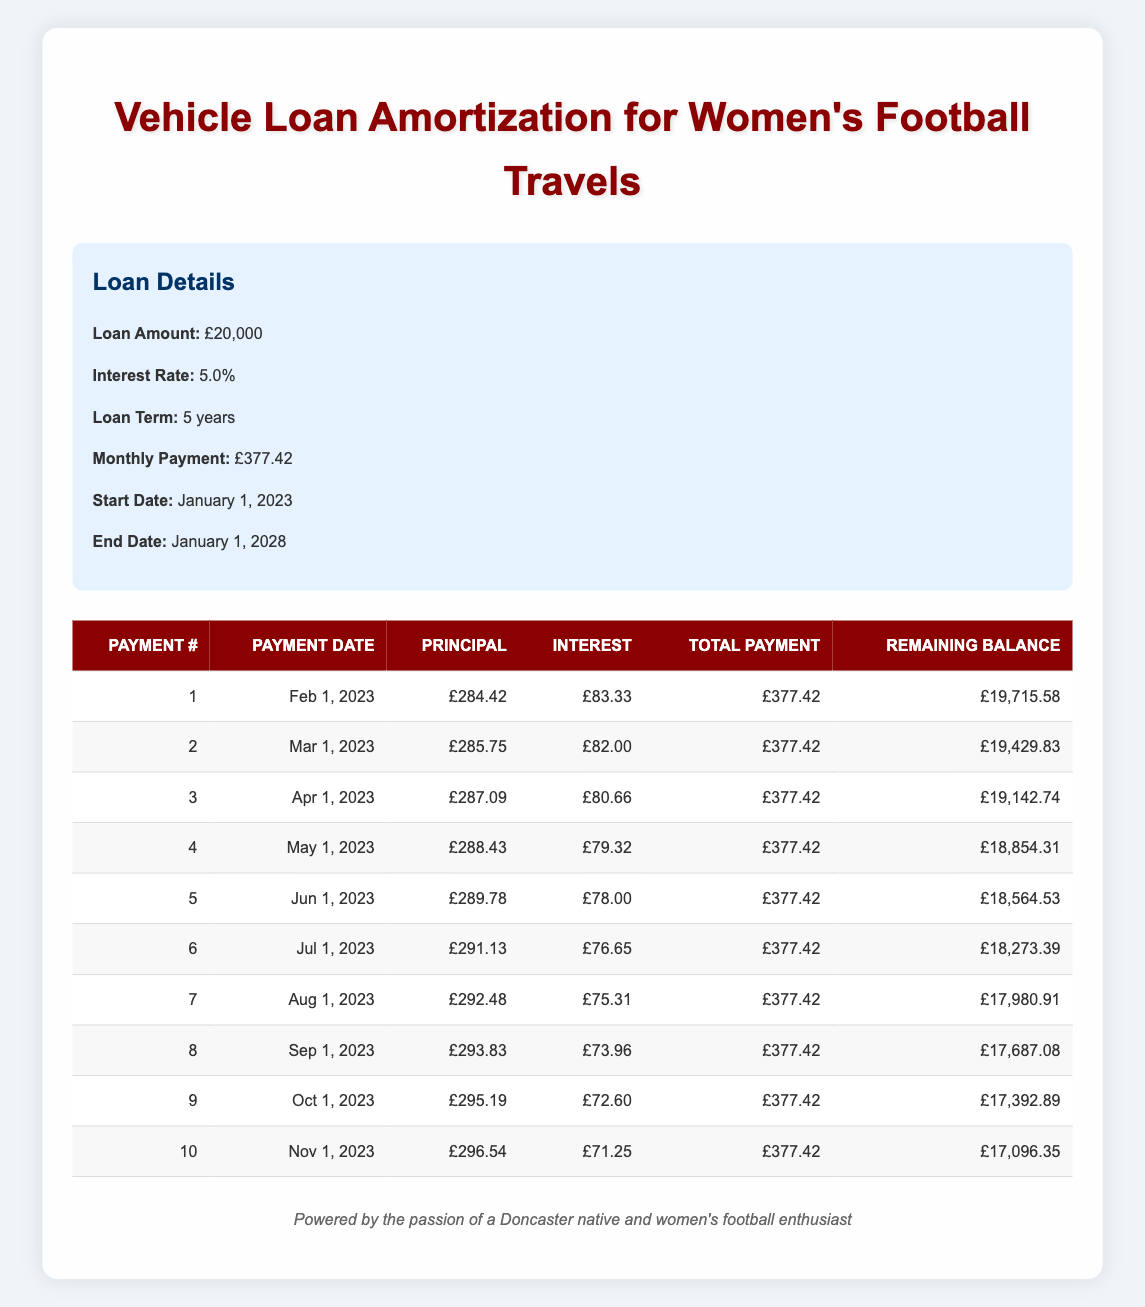What is the total amount paid after the first three payments? The first payment total is £377.42, the second is £377.42, and the third is £377.42. Adding these gives: 377.42 + 377.42 + 377.42 = 1132.26.
Answer: £1,132.26 What will be the remaining balance after the fifth payment? The remaining balance after the fifth payment is recorded in the table as £18,564.53.
Answer: £18,564.53 Is the interest payment decreasing with each payment? Looking at the interest payments in the table, they start from £83.33 and decrease to £78.00 by the fifth payment, indicating a downward trend.
Answer: Yes What is the total principal paid in the first 10 payments? The total principal for all 10 payments can be calculated by adding the principal payments: 284.42 + 285.75 + 287.09 + 288.43 + 289.78 + 291.13 + 292.48 + 293.83 + 295.19 + 296.54 = 2,865.64.
Answer: £2,865.64 What is the average monthly interest payment over the first 10 months? The total interest payments for the first 10 months are the sum: 83.33 + 82.00 + 80.66 + 79.32 + 78.00 + 76.65 + 75.31 + 73.96 + 72.60 + 71.25 = £798.08. To find the average, divide by 10: 798.08 / 10 = 79.81.
Answer: £79.81 Which payment had the highest principal amount? By checking the principal payments, the highest amount is £296.54, the tenth payment.
Answer: £296.54 What was the interest payment for the seventh payment? The interest payment for the seventh payment is listed as £75.31 in the table.
Answer: £75.31 What is the remaining balance after the first payment? The remaining balance after the first payment is recorded in the table as £19,715.58.
Answer: £19,715.58 